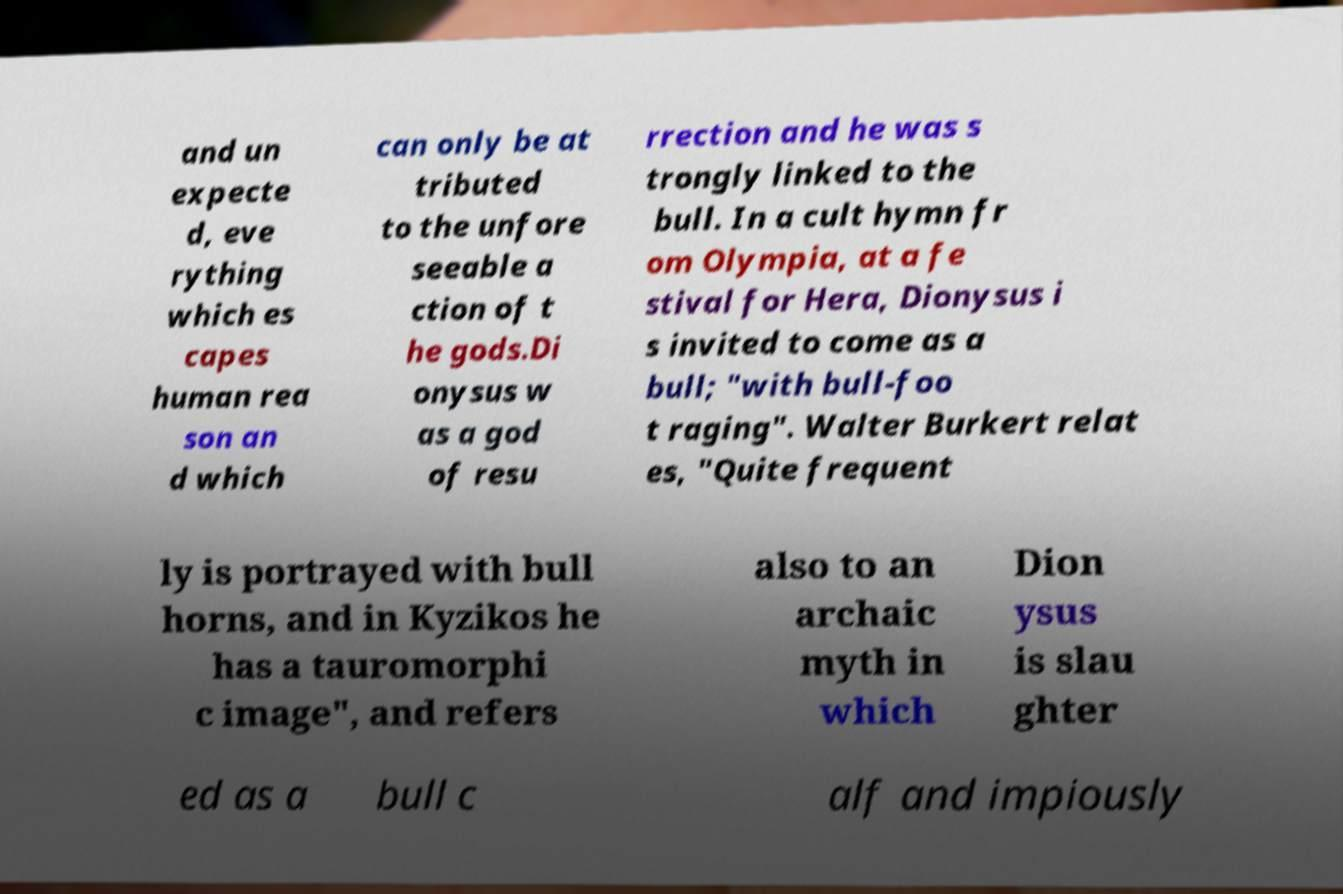Could you extract and type out the text from this image? and un expecte d, eve rything which es capes human rea son an d which can only be at tributed to the unfore seeable a ction of t he gods.Di onysus w as a god of resu rrection and he was s trongly linked to the bull. In a cult hymn fr om Olympia, at a fe stival for Hera, Dionysus i s invited to come as a bull; "with bull-foo t raging". Walter Burkert relat es, "Quite frequent ly is portrayed with bull horns, and in Kyzikos he has a tauromorphi c image", and refers also to an archaic myth in which Dion ysus is slau ghter ed as a bull c alf and impiously 